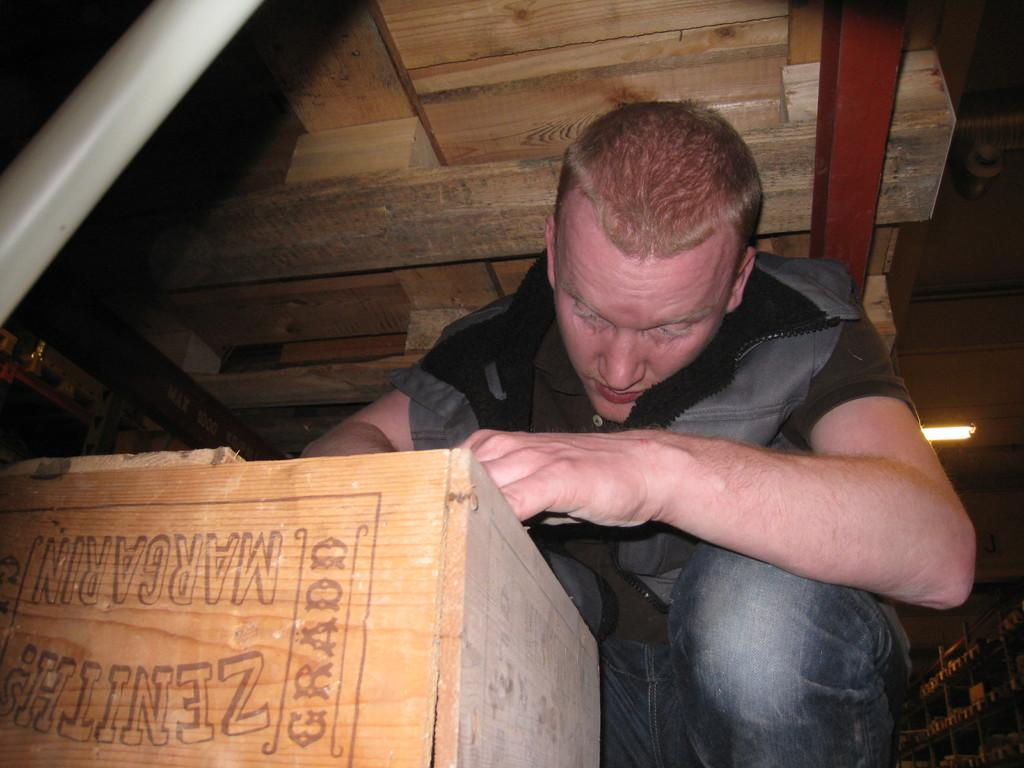Who or what is present in the image? There is a person in the image. What is the person wearing? The person is wearing a jacket. What object can be seen besides the person? There is a wooden box in the image. Where are the racks located in the image? The racks are in the bottom right corner of the image. What is the source of light in the image? A light is attached to the roof. Where is the person positioned in the image? The person is under a table. What type of division is visible in the image? There is no division present in the image; it is a single scene with a person, a wooden box, racks, and a light source. What kind of cap is the person wearing in the image? The person is not wearing a cap in the image; they are wearing a jacket. 